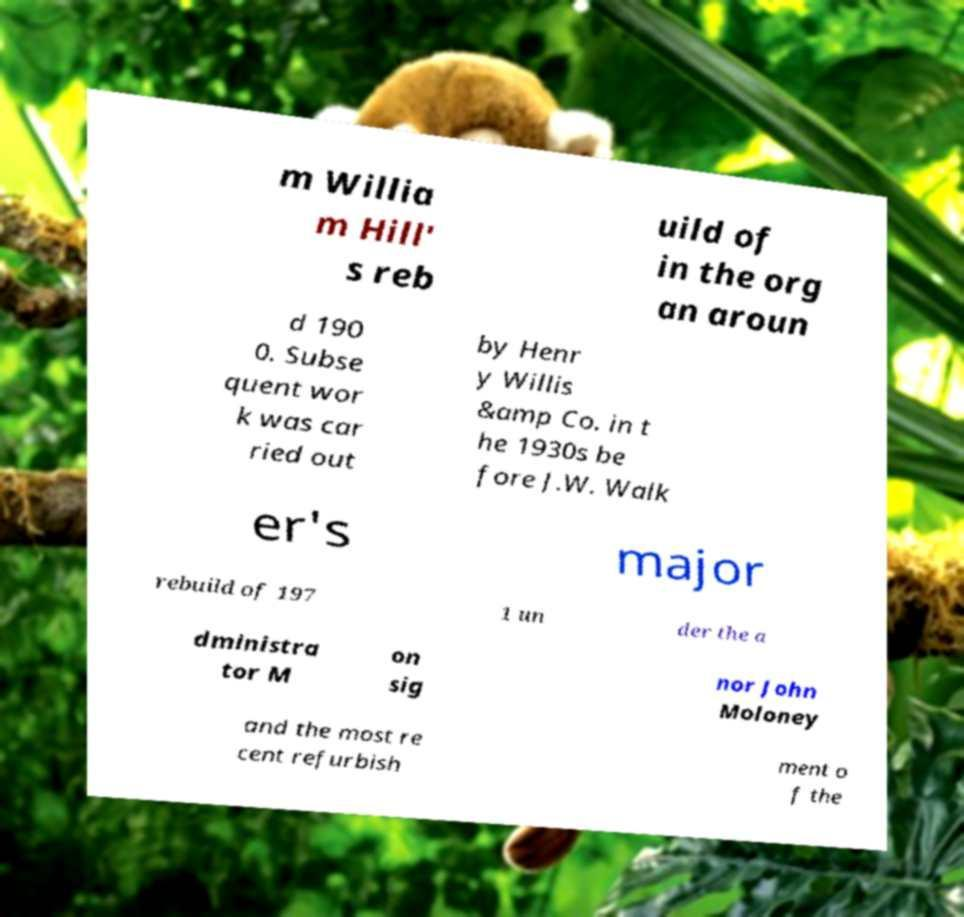I need the written content from this picture converted into text. Can you do that? m Willia m Hill' s reb uild of in the org an aroun d 190 0. Subse quent wor k was car ried out by Henr y Willis &amp Co. in t he 1930s be fore J.W. Walk er's major rebuild of 197 1 un der the a dministra tor M on sig nor John Moloney and the most re cent refurbish ment o f the 